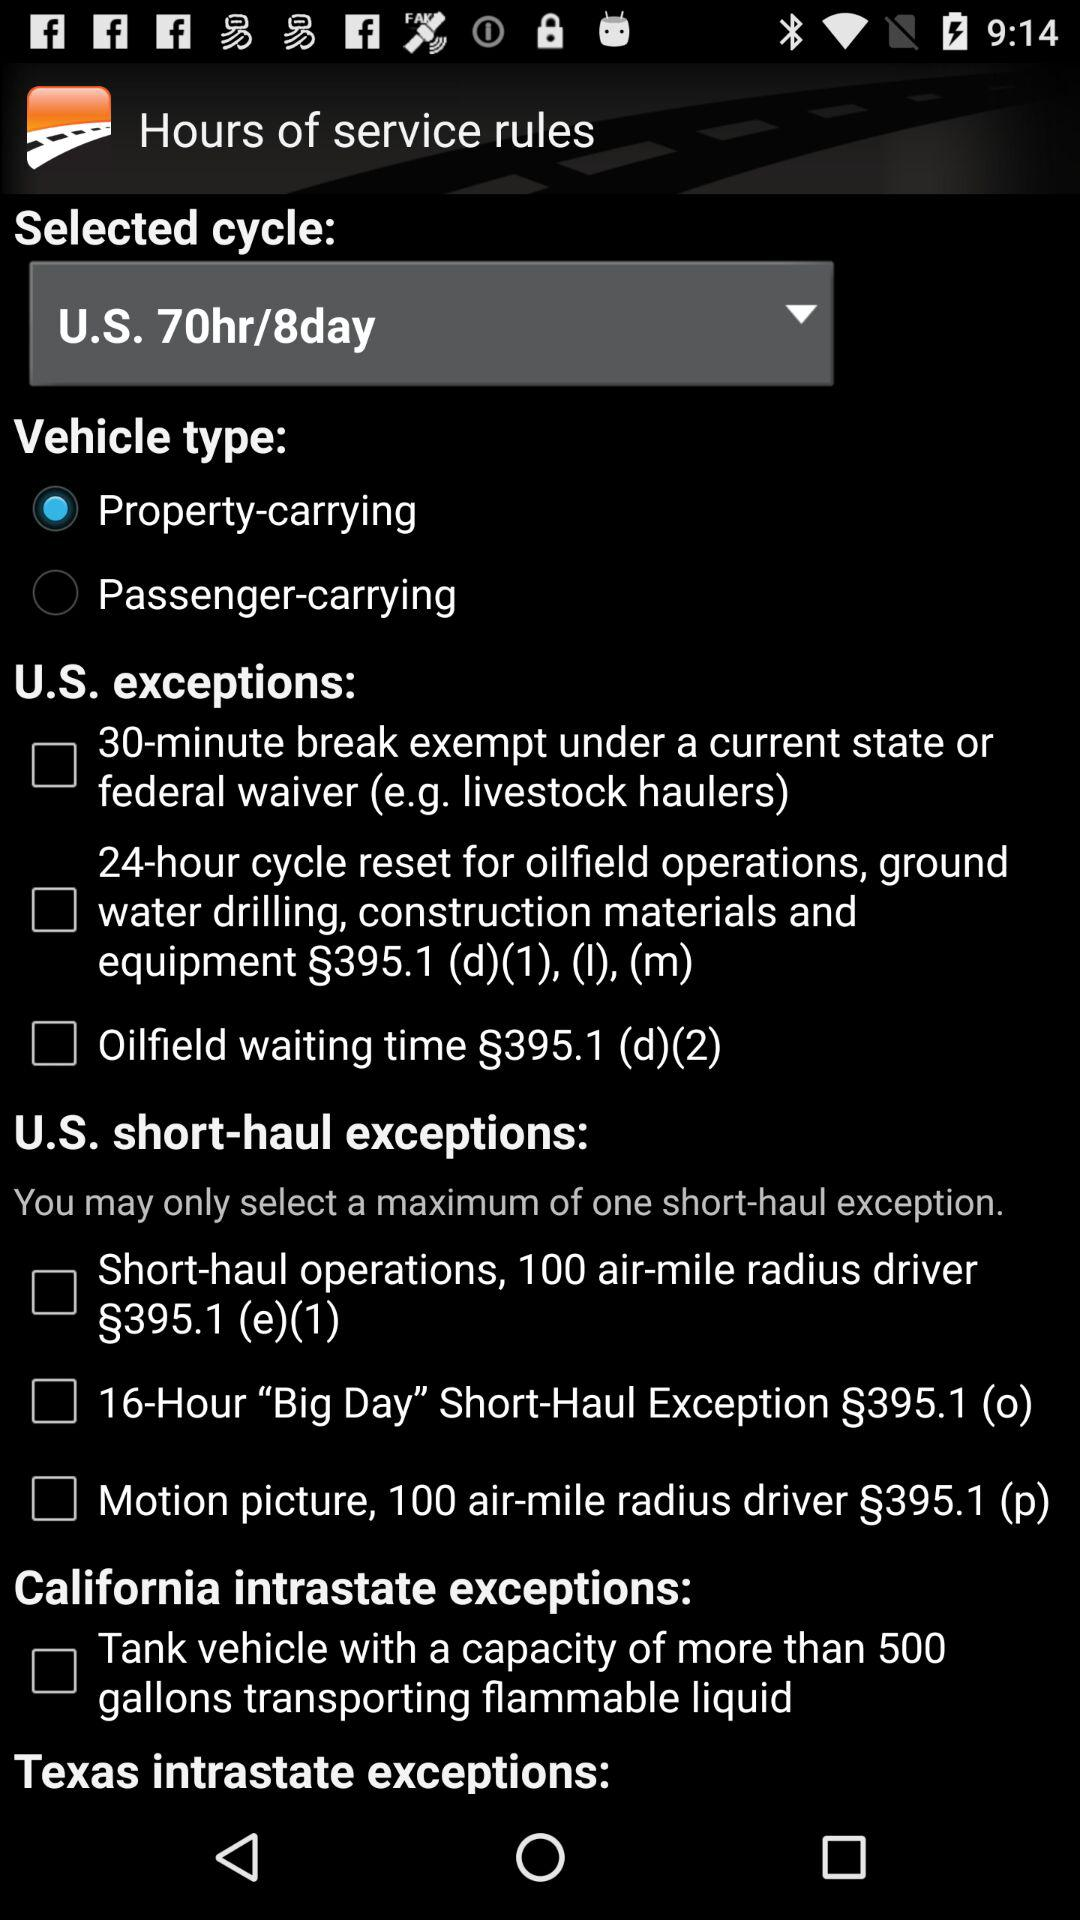What type of vehicle has been selected? The type of vehicle that has been selected is "Property-carrying". 